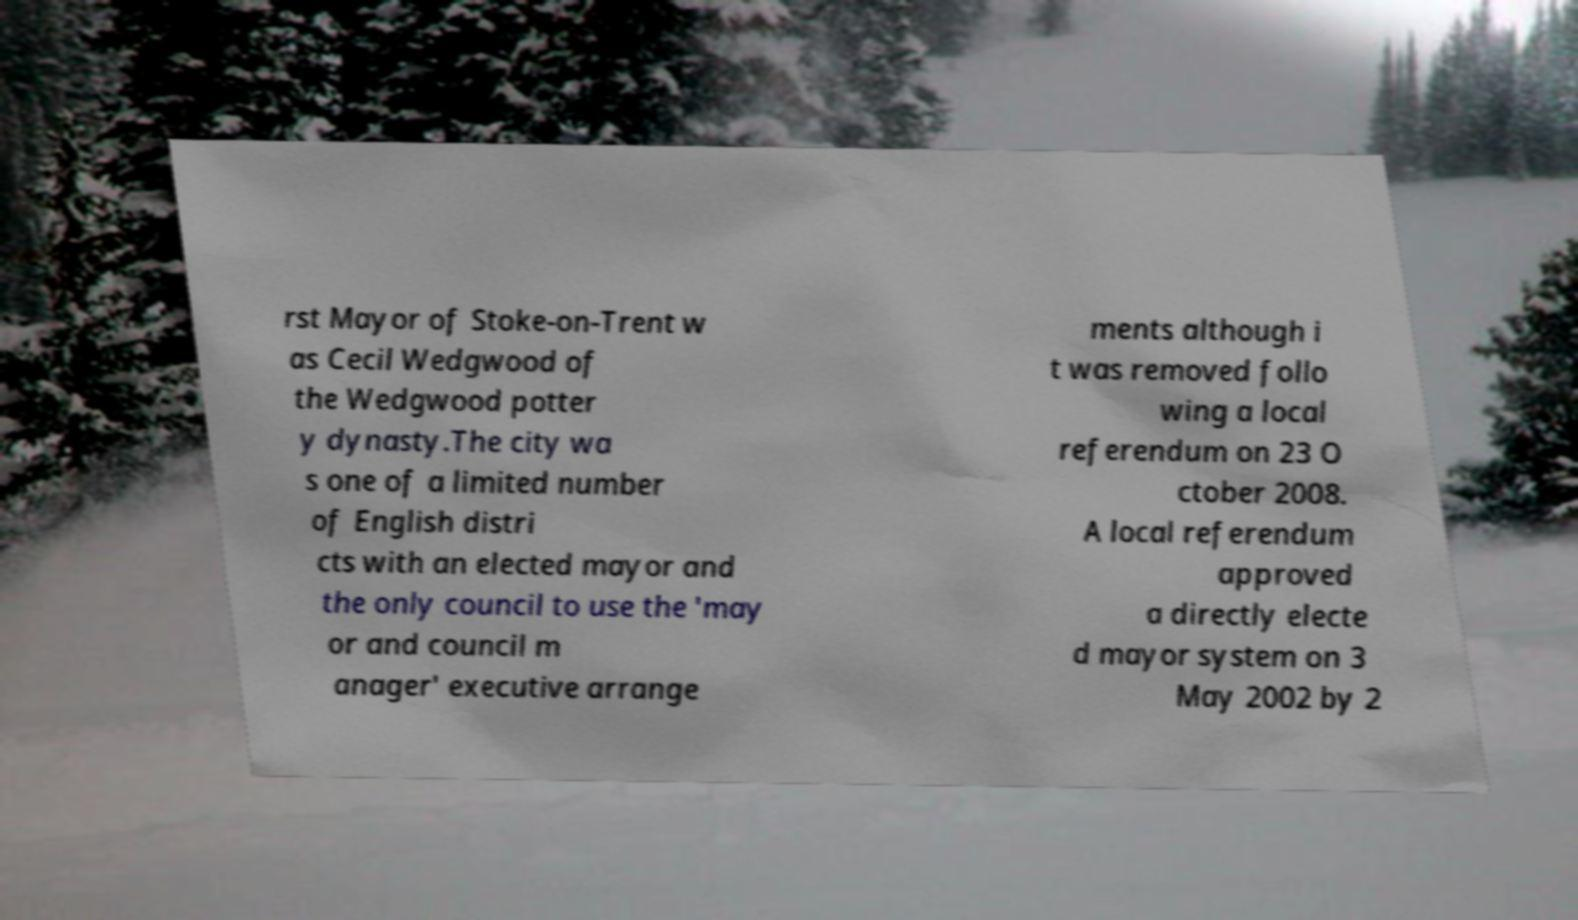There's text embedded in this image that I need extracted. Can you transcribe it verbatim? rst Mayor of Stoke-on-Trent w as Cecil Wedgwood of the Wedgwood potter y dynasty.The city wa s one of a limited number of English distri cts with an elected mayor and the only council to use the 'may or and council m anager' executive arrange ments although i t was removed follo wing a local referendum on 23 O ctober 2008. A local referendum approved a directly electe d mayor system on 3 May 2002 by 2 